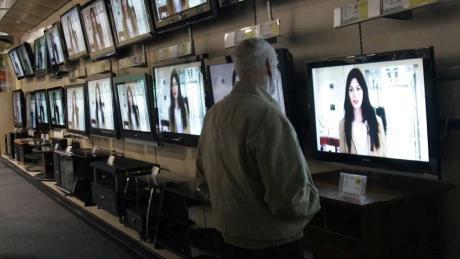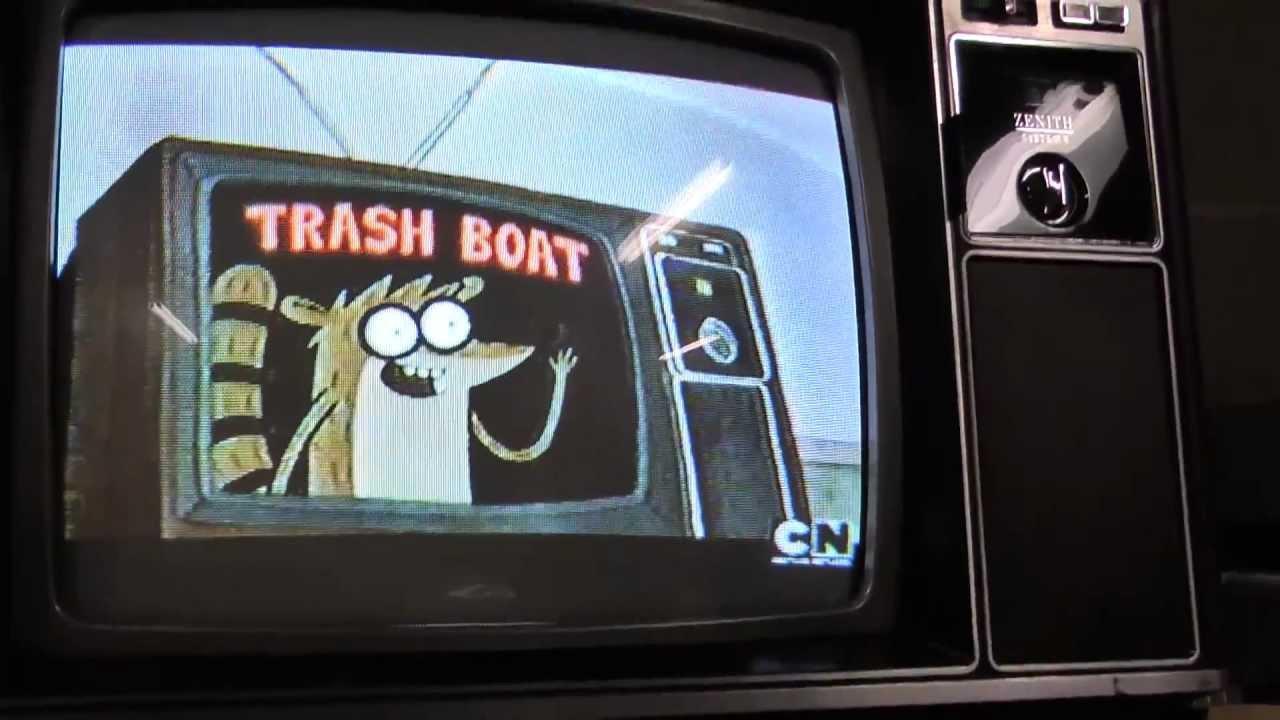The first image is the image on the left, the second image is the image on the right. Assess this claim about the two images: "At least one object sit atop the television in the image on the left.". Correct or not? Answer yes or no. No. 